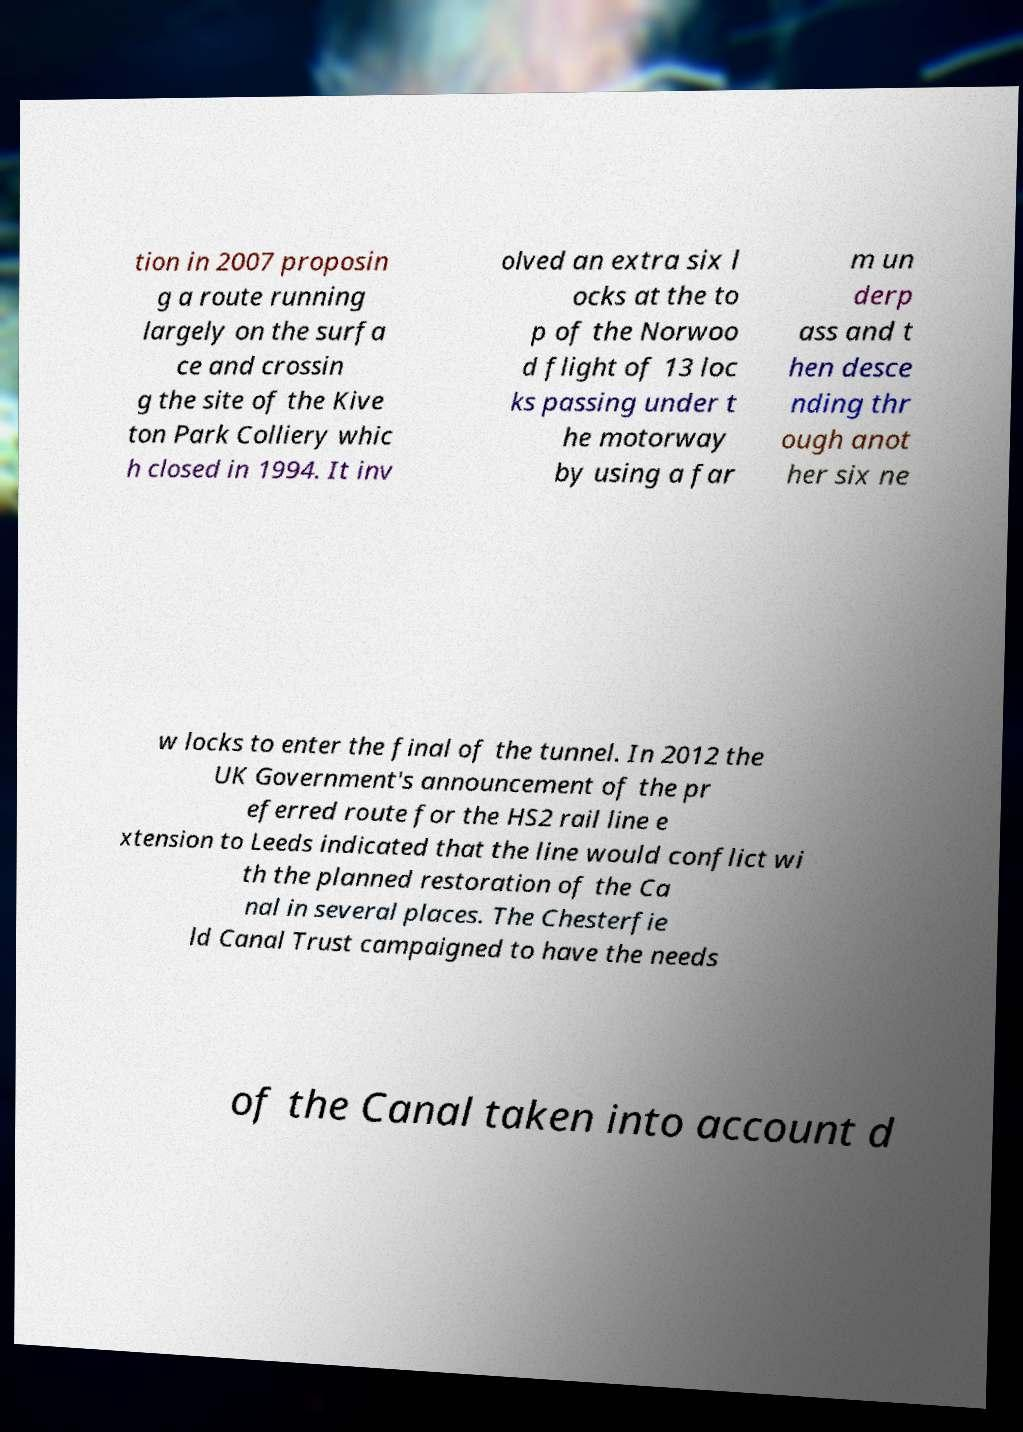What messages or text are displayed in this image? I need them in a readable, typed format. tion in 2007 proposin g a route running largely on the surfa ce and crossin g the site of the Kive ton Park Colliery whic h closed in 1994. It inv olved an extra six l ocks at the to p of the Norwoo d flight of 13 loc ks passing under t he motorway by using a far m un derp ass and t hen desce nding thr ough anot her six ne w locks to enter the final of the tunnel. In 2012 the UK Government's announcement of the pr eferred route for the HS2 rail line e xtension to Leeds indicated that the line would conflict wi th the planned restoration of the Ca nal in several places. The Chesterfie ld Canal Trust campaigned to have the needs of the Canal taken into account d 